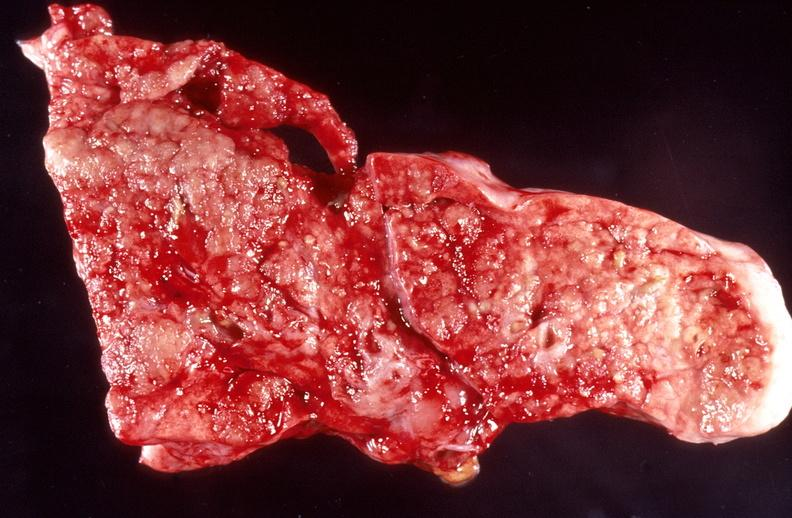s respiratory present?
Answer the question using a single word or phrase. Yes 